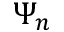Convert formula to latex. <formula><loc_0><loc_0><loc_500><loc_500>\Psi _ { n }</formula> 